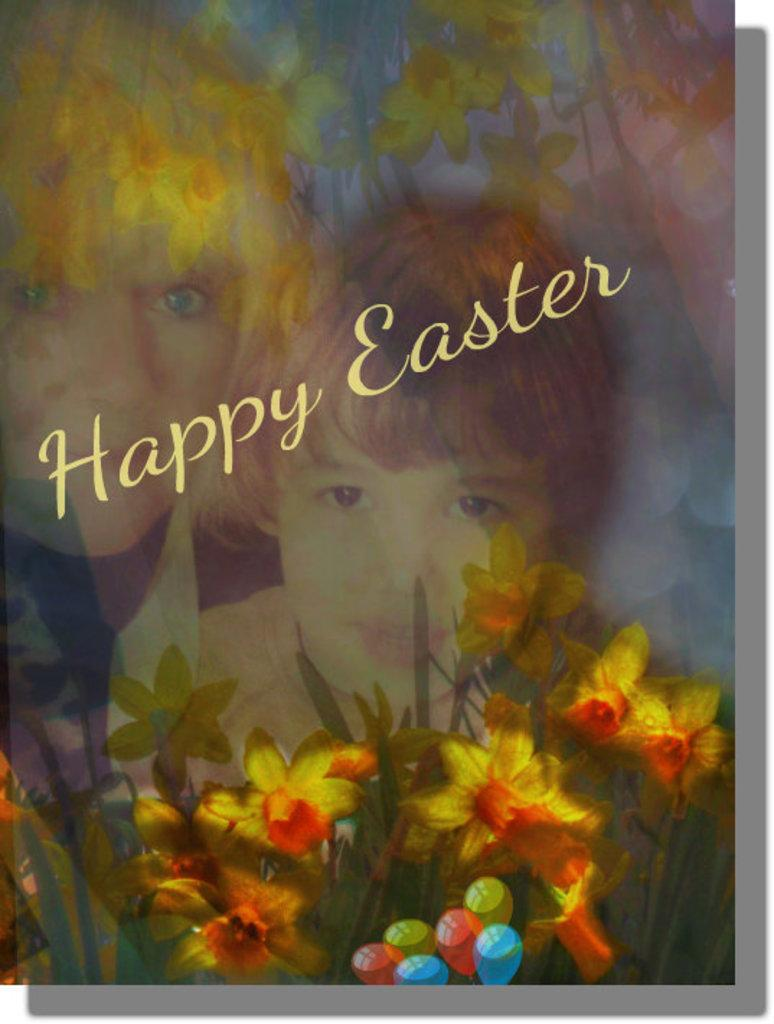What is the main subject of the image? The main subject of the image is a cover page. What message is conveyed on the cover page? The cover page has the text "Happy Easter" on it. What songs are being sung by the beggar in the image? There is no beggar or singing present in the image; it only features a cover page with the text "Happy Easter." 